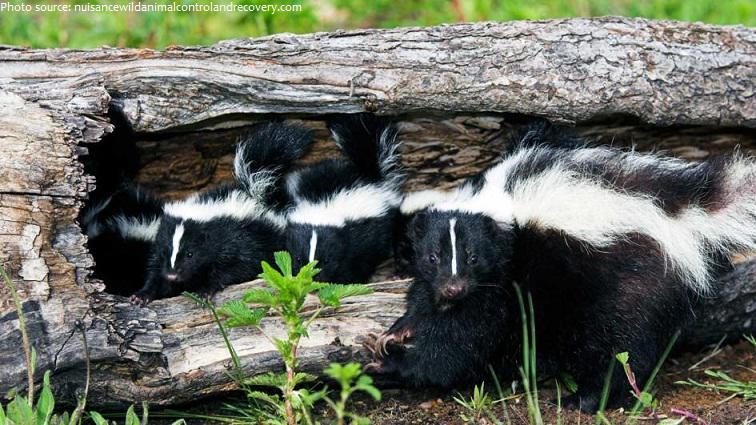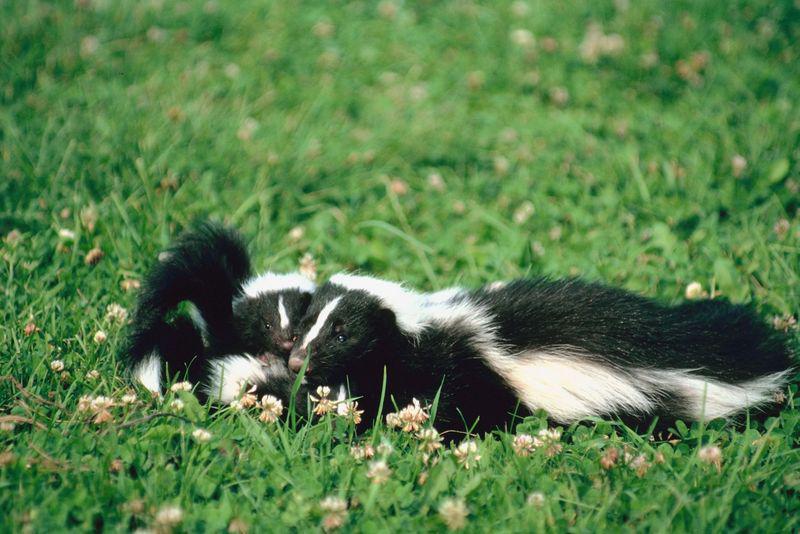The first image is the image on the left, the second image is the image on the right. Considering the images on both sides, is "The skunks in the right image have their tails up." valid? Answer yes or no. No. The first image is the image on the left, the second image is the image on the right. Analyze the images presented: Is the assertion "The three skunks on the right are sitting side-by-side in the grass." valid? Answer yes or no. No. 